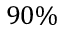Convert formula to latex. <formula><loc_0><loc_0><loc_500><loc_500>9 0 \%</formula> 